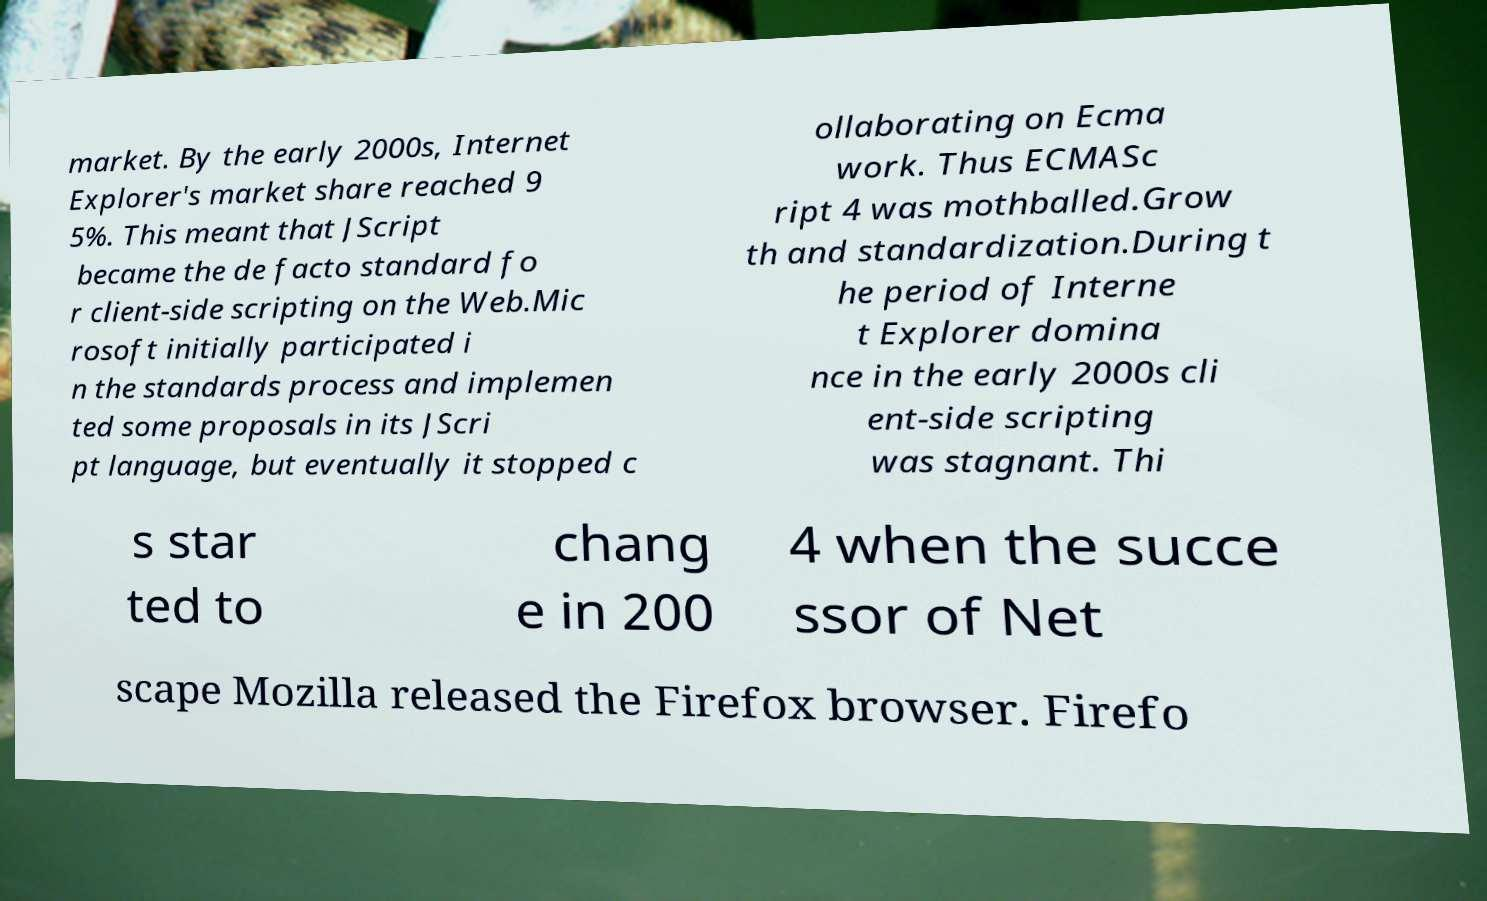Can you read and provide the text displayed in the image?This photo seems to have some interesting text. Can you extract and type it out for me? market. By the early 2000s, Internet Explorer's market share reached 9 5%. This meant that JScript became the de facto standard fo r client-side scripting on the Web.Mic rosoft initially participated i n the standards process and implemen ted some proposals in its JScri pt language, but eventually it stopped c ollaborating on Ecma work. Thus ECMASc ript 4 was mothballed.Grow th and standardization.During t he period of Interne t Explorer domina nce in the early 2000s cli ent-side scripting was stagnant. Thi s star ted to chang e in 200 4 when the succe ssor of Net scape Mozilla released the Firefox browser. Firefo 